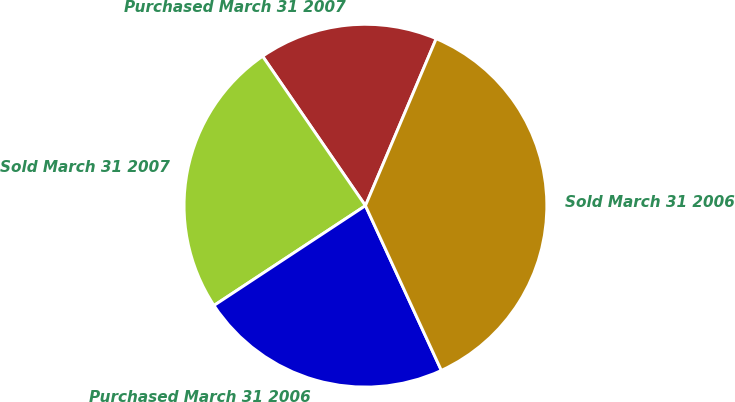<chart> <loc_0><loc_0><loc_500><loc_500><pie_chart><fcel>Purchased March 31 2007<fcel>Sold March 31 2007<fcel>Purchased March 31 2006<fcel>Sold March 31 2006<nl><fcel>15.97%<fcel>24.68%<fcel>22.6%<fcel>36.75%<nl></chart> 